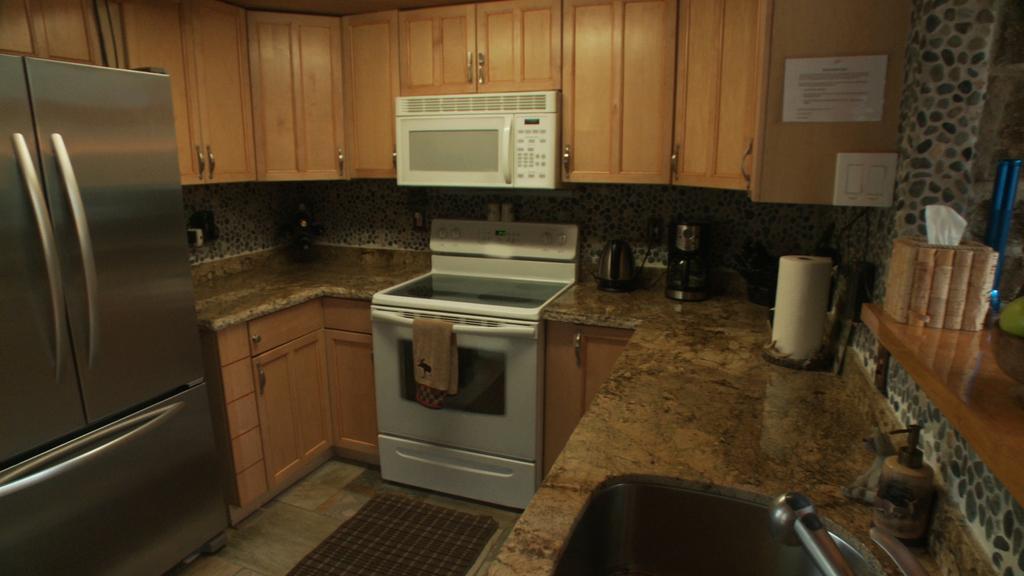Please provide a concise description of this image. In this image, we can see a kitchen and its appliances like a washing machine, an oven, a paper roll, a fridge and some cupboards with a poster on it. 